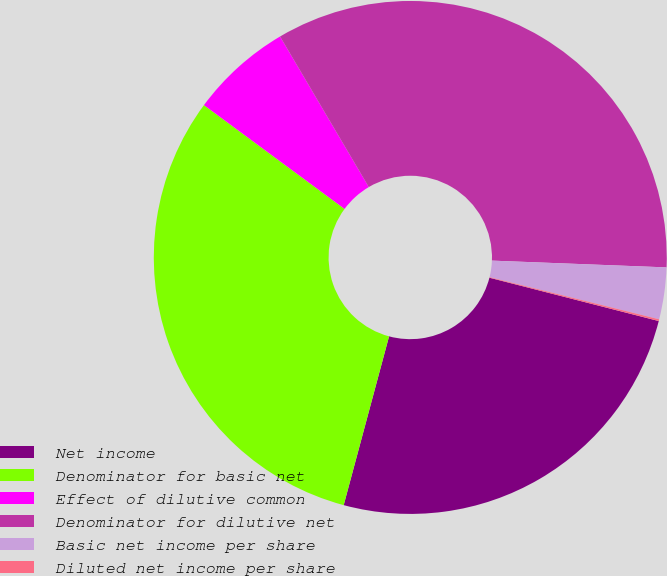Convert chart to OTSL. <chart><loc_0><loc_0><loc_500><loc_500><pie_chart><fcel>Net income<fcel>Denominator for basic net<fcel>Effect of dilutive common<fcel>Denominator for dilutive net<fcel>Basic net income per share<fcel>Diluted net income per share<nl><fcel>25.19%<fcel>30.94%<fcel>6.4%<fcel>34.09%<fcel>3.26%<fcel>0.11%<nl></chart> 